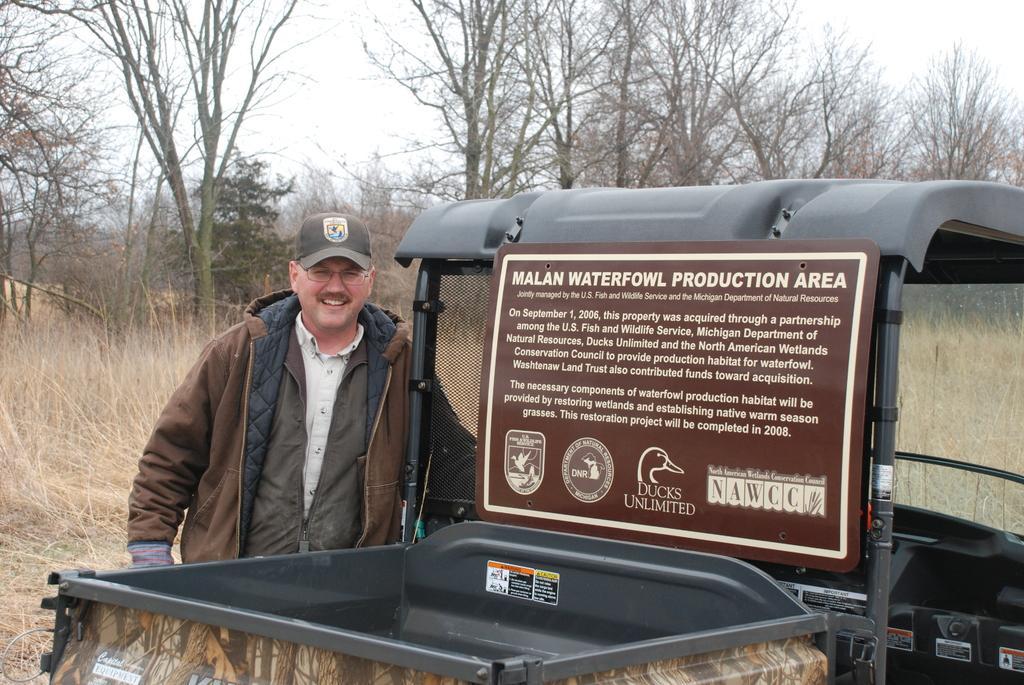Please provide a concise description of this image. In this image we can see a person who is standing side of the vehicle and in the background we can see a group of trees and grass. 